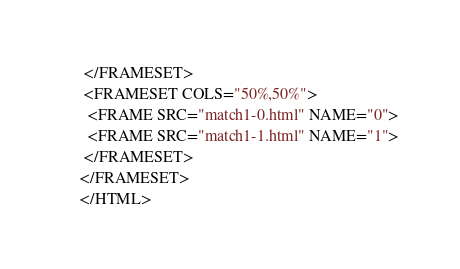Convert code to text. <code><loc_0><loc_0><loc_500><loc_500><_HTML_> </FRAMESET>
 <FRAMESET COLS="50%,50%">
  <FRAME SRC="match1-0.html" NAME="0">
  <FRAME SRC="match1-1.html" NAME="1">
 </FRAMESET>
</FRAMESET>
</HTML>
</code> 